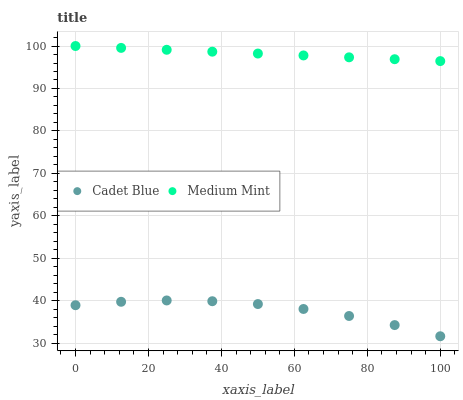Does Cadet Blue have the minimum area under the curve?
Answer yes or no. Yes. Does Medium Mint have the maximum area under the curve?
Answer yes or no. Yes. Does Cadet Blue have the maximum area under the curve?
Answer yes or no. No. Is Medium Mint the smoothest?
Answer yes or no. Yes. Is Cadet Blue the roughest?
Answer yes or no. Yes. Is Cadet Blue the smoothest?
Answer yes or no. No. Does Cadet Blue have the lowest value?
Answer yes or no. Yes. Does Medium Mint have the highest value?
Answer yes or no. Yes. Does Cadet Blue have the highest value?
Answer yes or no. No. Is Cadet Blue less than Medium Mint?
Answer yes or no. Yes. Is Medium Mint greater than Cadet Blue?
Answer yes or no. Yes. Does Cadet Blue intersect Medium Mint?
Answer yes or no. No. 